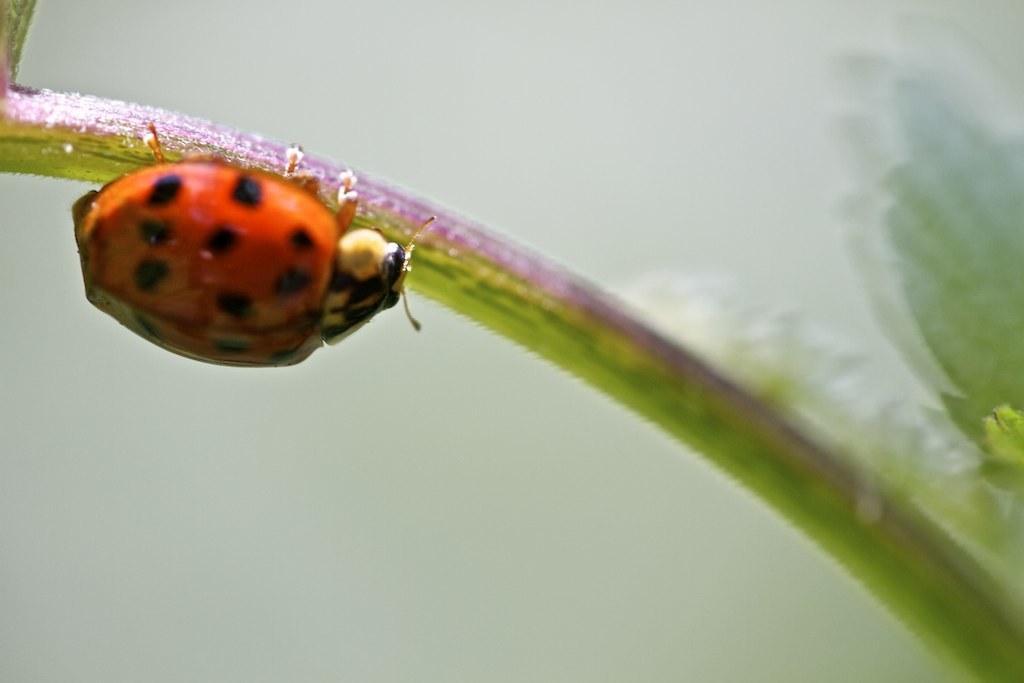In one or two sentences, can you explain what this image depicts? On the left side of the image we can see a bug on the stem. 